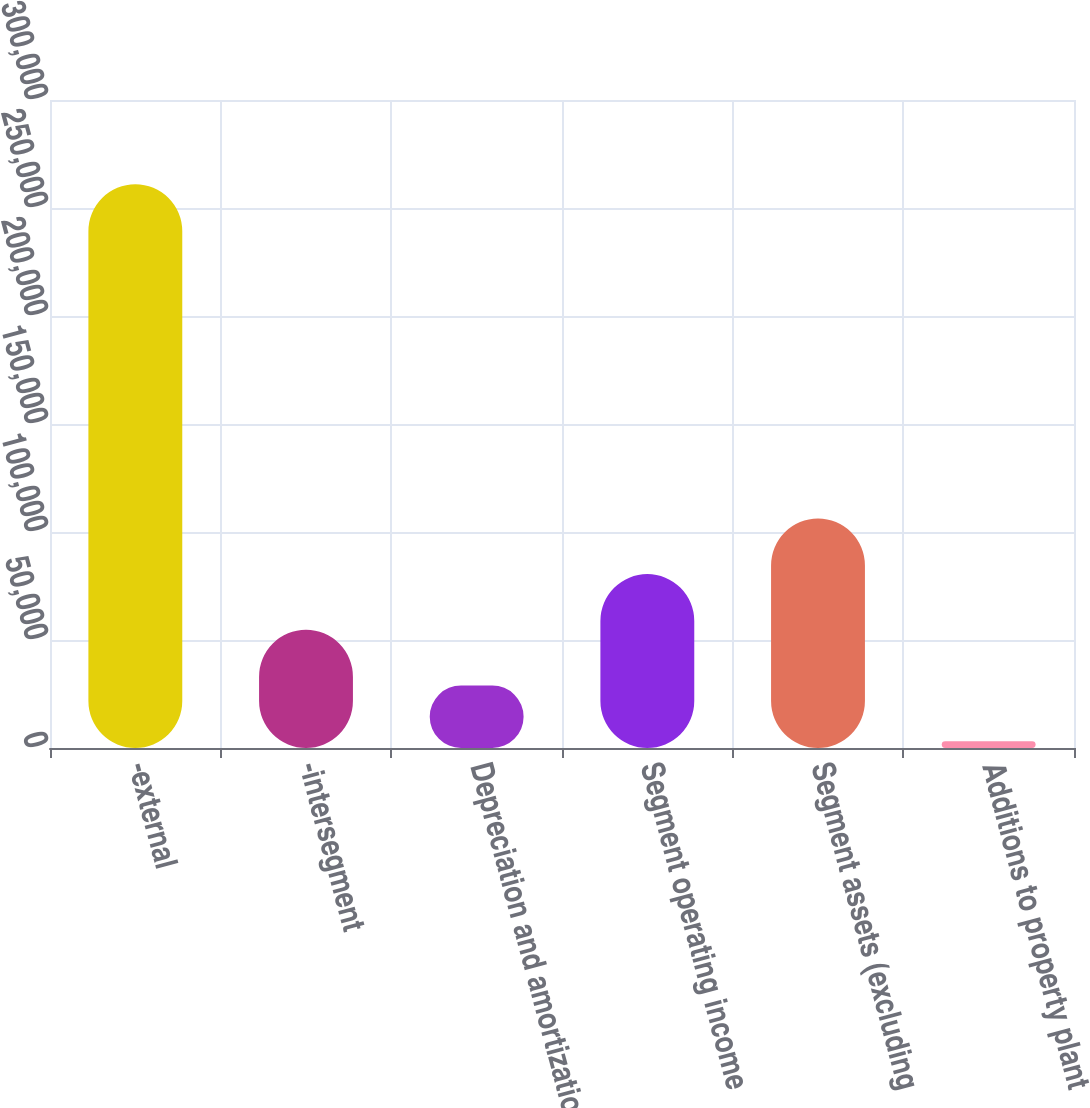Convert chart. <chart><loc_0><loc_0><loc_500><loc_500><bar_chart><fcel>-external<fcel>-intersegment<fcel>Depreciation and amortization<fcel>Segment operating income<fcel>Segment assets (excluding<fcel>Additions to property plant<nl><fcel>260982<fcel>54728.4<fcel>28946.7<fcel>80510.1<fcel>106292<fcel>3165<nl></chart> 